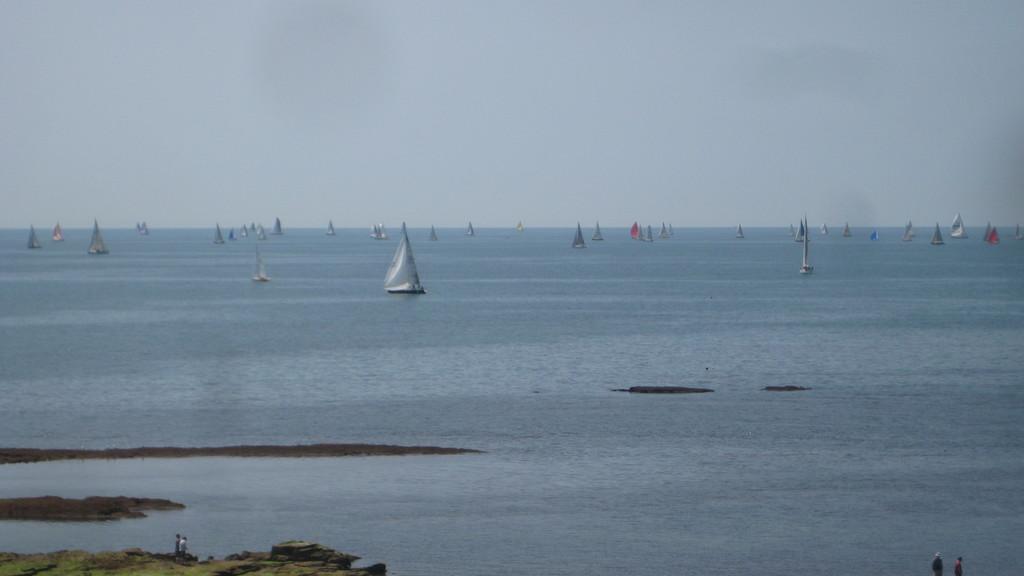In one or two sentences, can you explain what this image depicts? In the image we can see there are many boats in the water. There are even people standing and wearing clothes. Here we can see grass and a sky. 